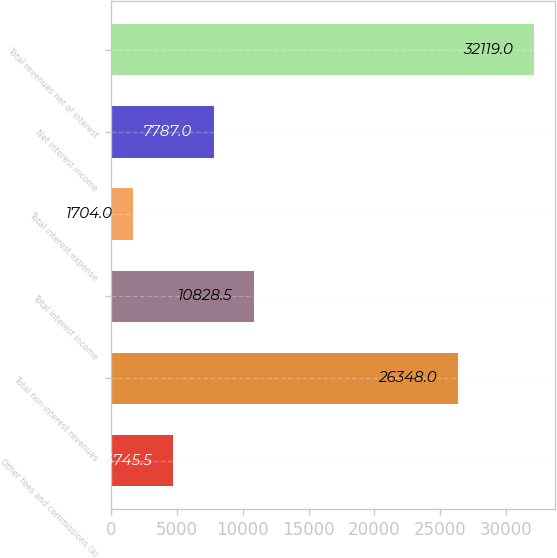Convert chart. <chart><loc_0><loc_0><loc_500><loc_500><bar_chart><fcel>Other fees and commissions (a)<fcel>Total non-interest revenues<fcel>Total interest income<fcel>Total interest expense<fcel>Net interest income<fcel>Total revenues net of interest<nl><fcel>4745.5<fcel>26348<fcel>10828.5<fcel>1704<fcel>7787<fcel>32119<nl></chart> 